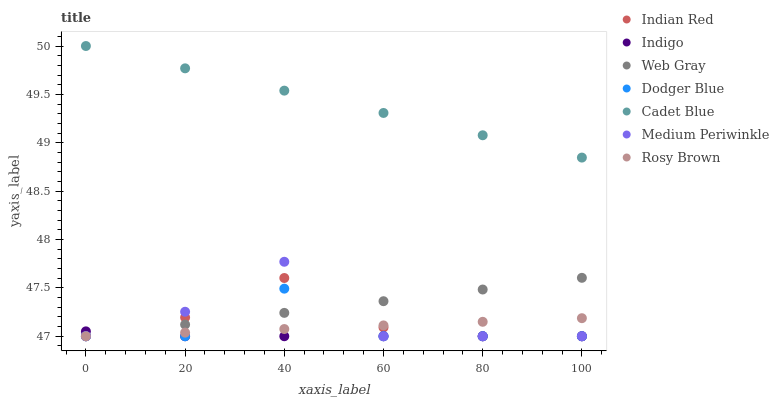Does Indigo have the minimum area under the curve?
Answer yes or no. Yes. Does Cadet Blue have the maximum area under the curve?
Answer yes or no. Yes. Does Rosy Brown have the minimum area under the curve?
Answer yes or no. No. Does Rosy Brown have the maximum area under the curve?
Answer yes or no. No. Is Rosy Brown the smoothest?
Answer yes or no. Yes. Is Medium Periwinkle the roughest?
Answer yes or no. Yes. Is Indigo the smoothest?
Answer yes or no. No. Is Indigo the roughest?
Answer yes or no. No. Does Indigo have the lowest value?
Answer yes or no. Yes. Does Cadet Blue have the highest value?
Answer yes or no. Yes. Does Rosy Brown have the highest value?
Answer yes or no. No. Is Web Gray less than Cadet Blue?
Answer yes or no. Yes. Is Cadet Blue greater than Web Gray?
Answer yes or no. Yes. Does Indigo intersect Web Gray?
Answer yes or no. Yes. Is Indigo less than Web Gray?
Answer yes or no. No. Is Indigo greater than Web Gray?
Answer yes or no. No. Does Web Gray intersect Cadet Blue?
Answer yes or no. No. 